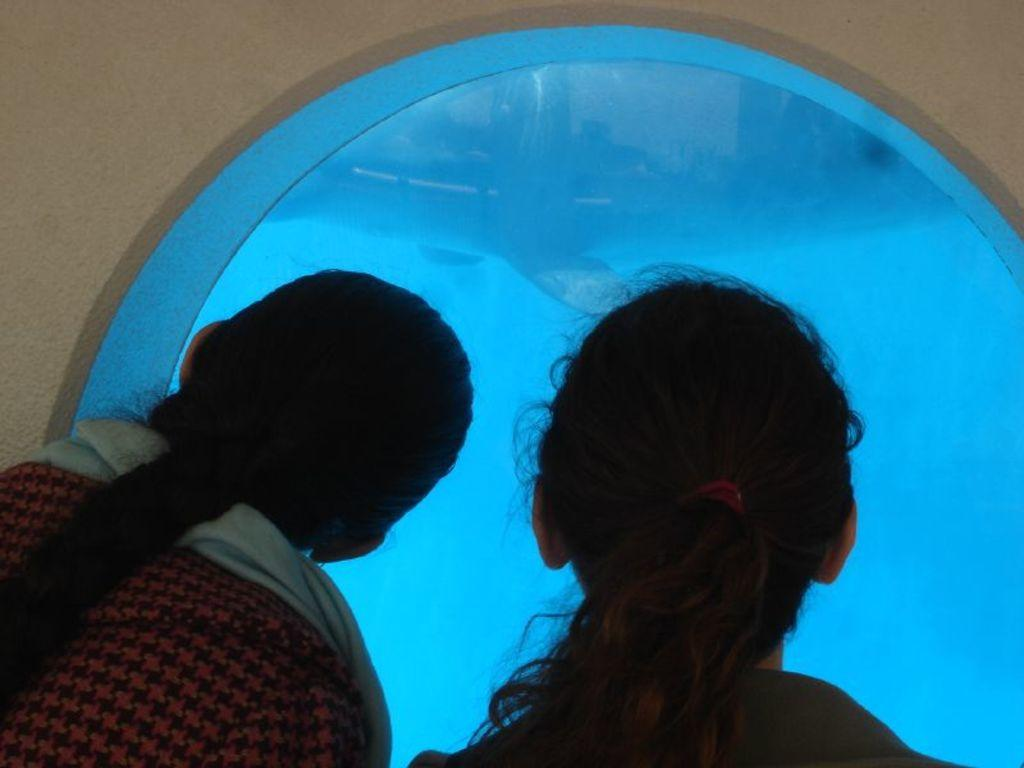How many people are visible in the image? There are two persons in the front of the image. What can be seen behind the people in the image? There is a wall in the background of the image. What time of day is it in the image, based on the presence of a basin? There is no basin present in the image, so it cannot be determined what time of day it is based on that object. 